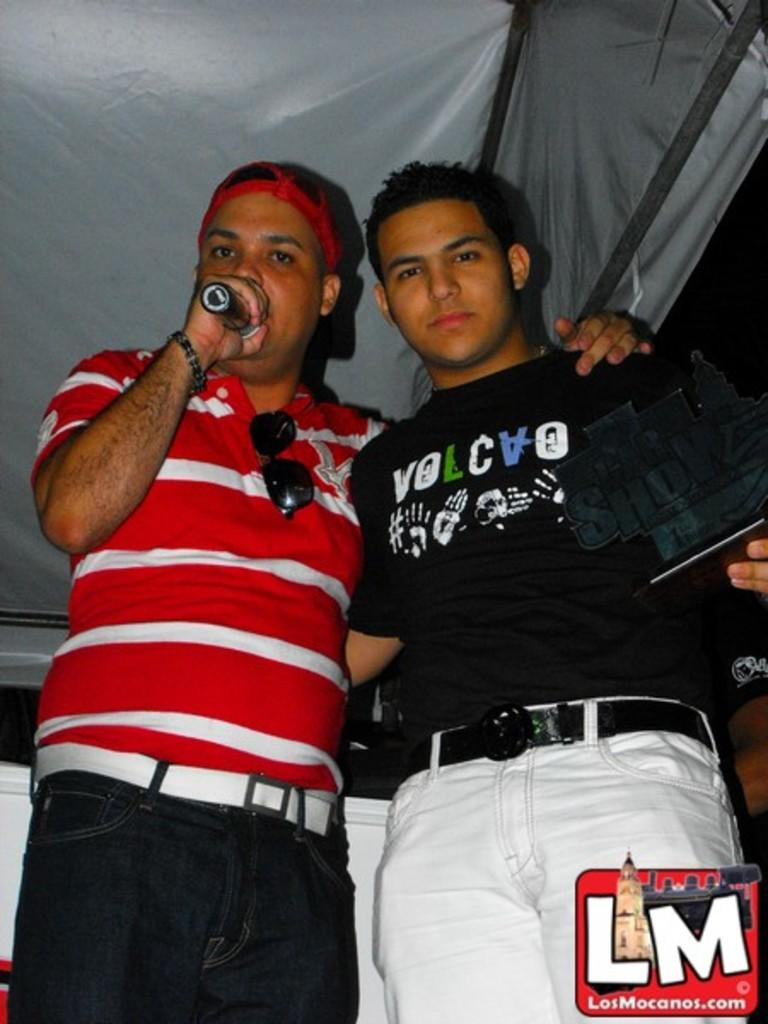How many people are in the image? There are two men standing in the center of the image. What can be seen in the background of the image? There is a tent and a wall in the background of the image, as well as the sky. Can you describe the position of the men in the image? The men are standing in the center of the image. What type of string is being used to hold up the body in the image? There is no body or string present in the image; it features two men standing and a background with a tent, wall, and sky. 